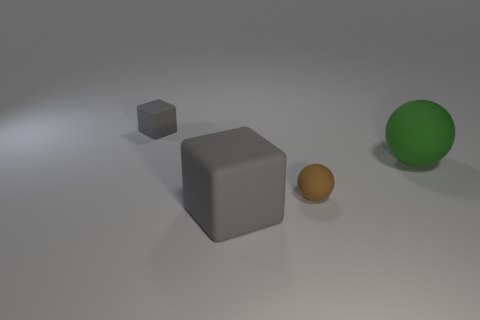There is a thing that is the same color as the small cube; what is its size?
Your answer should be compact. Large. The brown matte object has what shape?
Provide a short and direct response. Sphere. Is the color of the big rubber sphere the same as the big cube?
Keep it short and to the point. No. There is a rubber thing that is the same size as the green matte sphere; what color is it?
Give a very brief answer. Gray. How many gray things are tiny things or rubber things?
Your answer should be very brief. 2. Is the number of green objects greater than the number of cyan metallic balls?
Make the answer very short. Yes. Is the size of the gray matte object that is in front of the big green ball the same as the gray rubber thing behind the small rubber ball?
Make the answer very short. No. What is the color of the tiny thing that is to the right of the gray cube that is behind the large object that is in front of the small brown matte object?
Provide a succinct answer. Brown. Is there a big green rubber thing that has the same shape as the tiny brown object?
Give a very brief answer. Yes. Is the number of large cubes in front of the green rubber object greater than the number of small red balls?
Your answer should be very brief. Yes. 